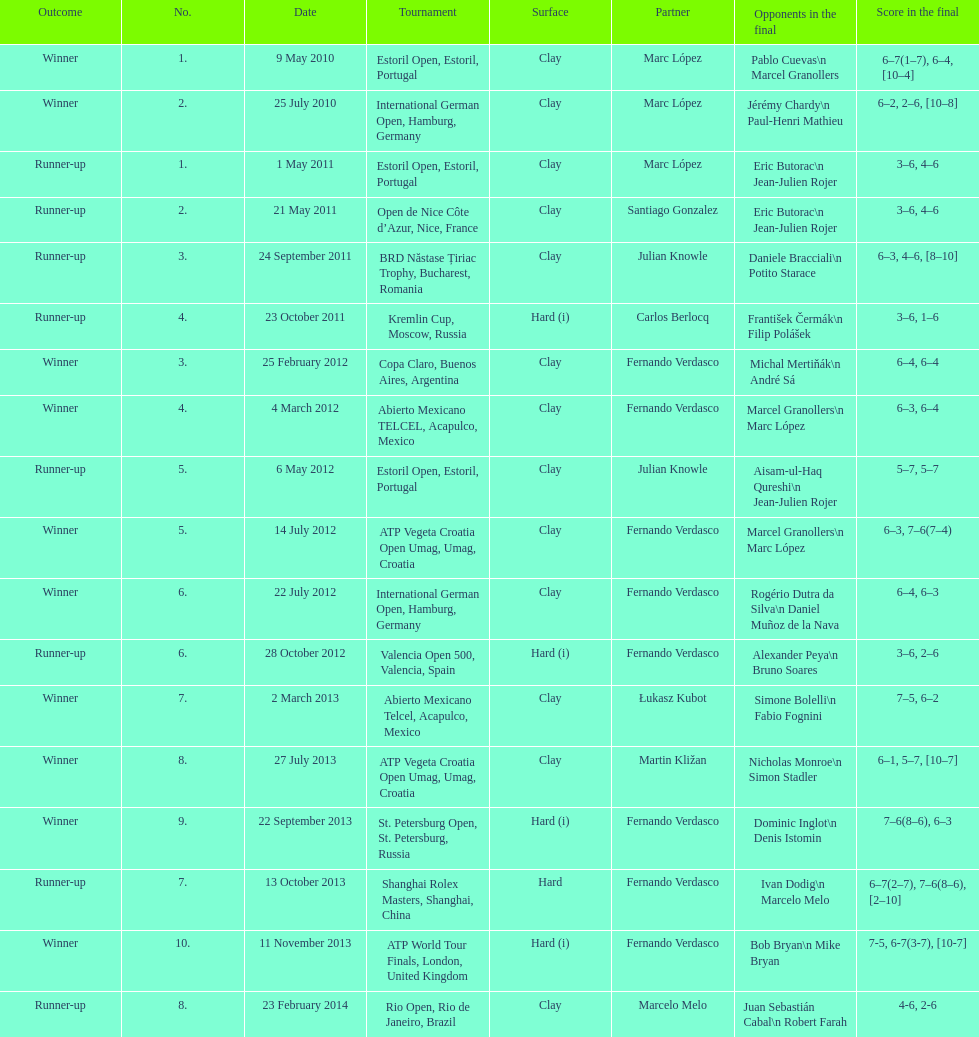Who was this player's next partner after playing with marc lopez in may 2011? Santiago Gonzalez. 